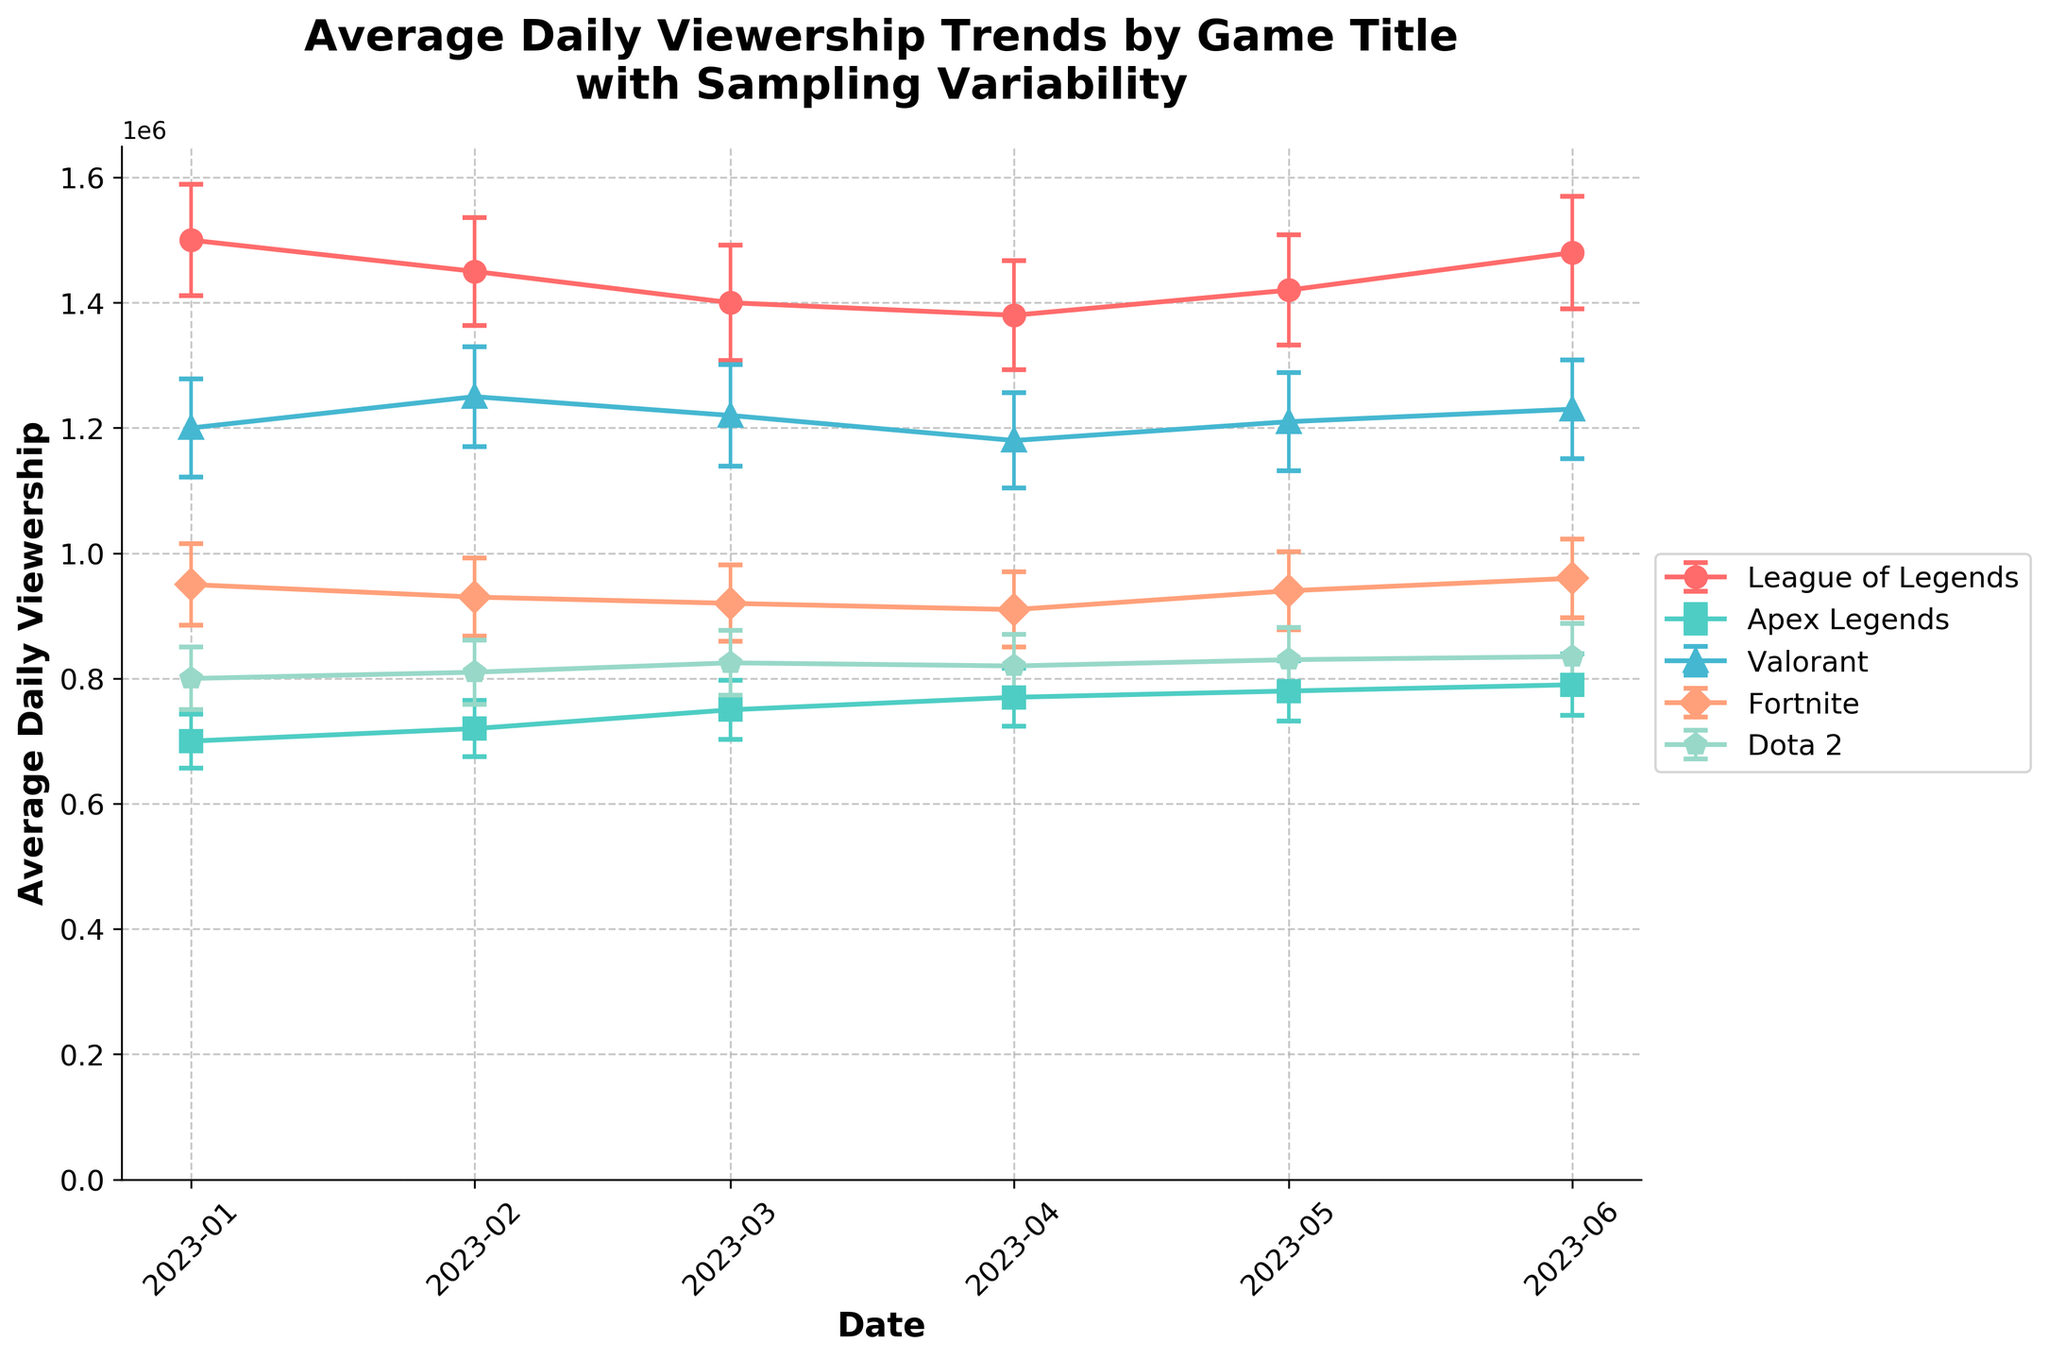What is the title of the plot? The title is prominently displayed at the top of the plot. It reads "Average Daily Viewership Trends by Game Title with Sampling Variability".
Answer: "Average Daily Viewership Trends by Game Title with Sampling Variability" Which game had the highest average daily viewership in June 2023? By examining the plotted lines and corresponding labels, the highest point in June 2023 corresponds to "League of Legends".
Answer: League of Legends Which game has the smallest error bars in the month of April 2023? Look at all the error bars in April for each game. The smallest error bar belongs to "Fortnite" as it has the shortest vertical error line.
Answer: Fortnite Which month experienced a peak in average daily viewership for Apex Legends? Follow the line of Apex Legends across the months. The peak happens in June 2023, where the highest point is observed.
Answer: June 2023 How did Valorant's average daily viewership in February compare to its viewership in March 2023? Compare the endpoints for Valorant in February and March. The average daily viewership is higher in February than in March.
Answer: Higher in February 2023 Which game showed an increasing trend from January to June 2023? Examine the slope of the lines. "Dota 2" shows a consistent upward trend from January to June 2023.
Answer: Dota 2 What are the colors used to represent League of Legends and Apex Legends? By looking at the legend, "League of Legends" is represented by red, and "Apex Legends" is represented by a teal-like color.
Answer: Red for League of Legends, Teal for Apex Legends What is the overall trend for League of Legends from January to June 2023? Follow the line representing League of Legends from January to June; it shows a slight decline then rises again towards June.
Answer: Slight decline followed by a rise How many game titles are presented in the plot? Counting all unique titles listed in the legend, there are five: League of Legends, Apex Legends, Valorant, Fortnite, and Dota 2.
Answer: Five What is the y-axis labeled as, and what does it represent? The y-axis label is "Average Daily Viewership," indicating the vertical metric represents the number of average viewers per day.
Answer: "Average Daily Viewership", it represents the number of average viewers per day 